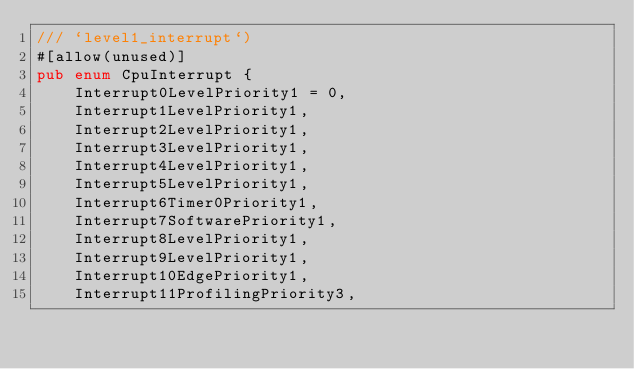Convert code to text. <code><loc_0><loc_0><loc_500><loc_500><_Rust_>/// `level1_interrupt`)
#[allow(unused)]
pub enum CpuInterrupt {
    Interrupt0LevelPriority1 = 0,
    Interrupt1LevelPriority1,
    Interrupt2LevelPriority1,
    Interrupt3LevelPriority1,
    Interrupt4LevelPriority1,
    Interrupt5LevelPriority1,
    Interrupt6Timer0Priority1,
    Interrupt7SoftwarePriority1,
    Interrupt8LevelPriority1,
    Interrupt9LevelPriority1,
    Interrupt10EdgePriority1,
    Interrupt11ProfilingPriority3,</code> 